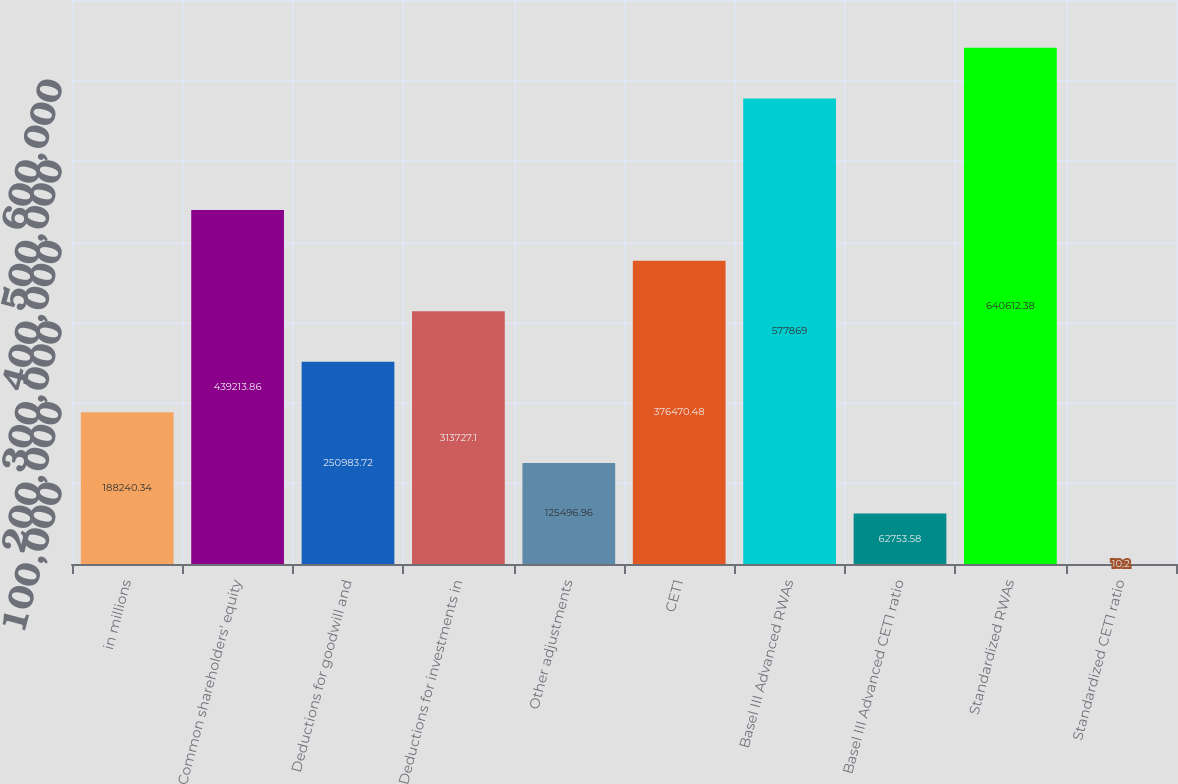<chart> <loc_0><loc_0><loc_500><loc_500><bar_chart><fcel>in millions<fcel>Common shareholders' equity<fcel>Deductions for goodwill and<fcel>Deductions for investments in<fcel>Other adjustments<fcel>CET1<fcel>Basel III Advanced RWAs<fcel>Basel III Advanced CET1 ratio<fcel>Standardized RWAs<fcel>Standardized CET1 ratio<nl><fcel>188240<fcel>439214<fcel>250984<fcel>313727<fcel>125497<fcel>376470<fcel>577869<fcel>62753.6<fcel>640612<fcel>10.2<nl></chart> 